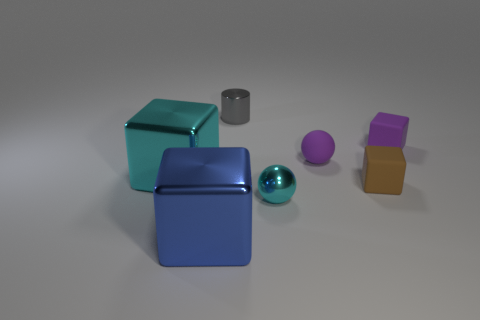Subtract 1 cubes. How many cubes are left? 3 Add 3 gray balls. How many objects exist? 10 Subtract all cubes. How many objects are left? 3 Add 4 small gray metal things. How many small gray metal things are left? 5 Add 3 cyan objects. How many cyan objects exist? 5 Subtract 0 blue spheres. How many objects are left? 7 Subtract all purple rubber spheres. Subtract all small gray metallic cylinders. How many objects are left? 5 